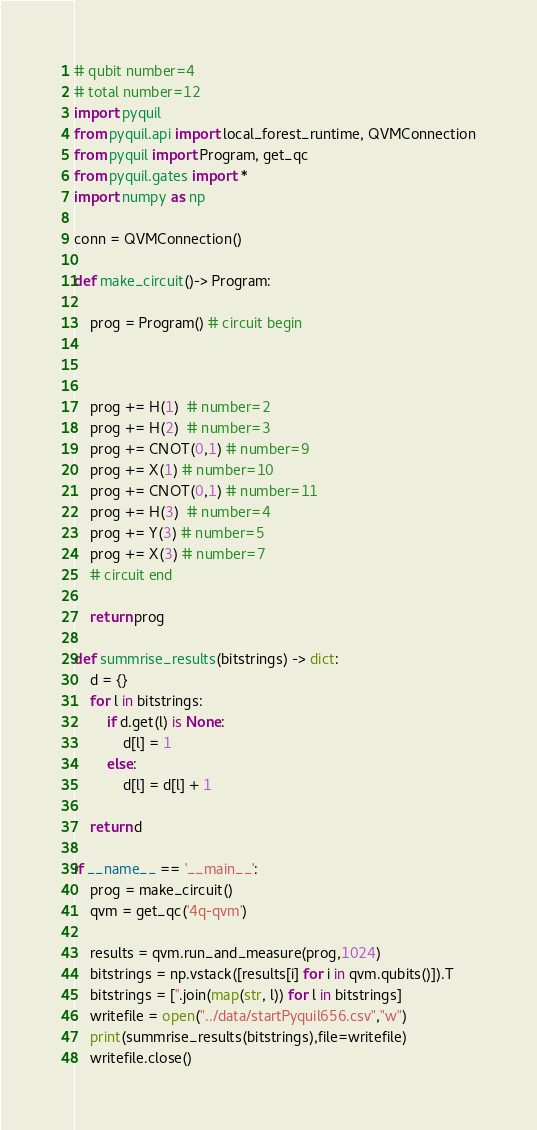<code> <loc_0><loc_0><loc_500><loc_500><_Python_># qubit number=4
# total number=12
import pyquil
from pyquil.api import local_forest_runtime, QVMConnection
from pyquil import Program, get_qc
from pyquil.gates import *
import numpy as np

conn = QVMConnection()

def make_circuit()-> Program:

    prog = Program() # circuit begin



    prog += H(1)  # number=2
    prog += H(2)  # number=3
    prog += CNOT(0,1) # number=9
    prog += X(1) # number=10
    prog += CNOT(0,1) # number=11
    prog += H(3)  # number=4
    prog += Y(3) # number=5
    prog += X(3) # number=7
    # circuit end

    return prog

def summrise_results(bitstrings) -> dict:
    d = {}
    for l in bitstrings:
        if d.get(l) is None:
            d[l] = 1
        else:
            d[l] = d[l] + 1

    return d

if __name__ == '__main__':
    prog = make_circuit()
    qvm = get_qc('4q-qvm')

    results = qvm.run_and_measure(prog,1024)
    bitstrings = np.vstack([results[i] for i in qvm.qubits()]).T
    bitstrings = [''.join(map(str, l)) for l in bitstrings]
    writefile = open("../data/startPyquil656.csv","w")
    print(summrise_results(bitstrings),file=writefile)
    writefile.close()

</code> 